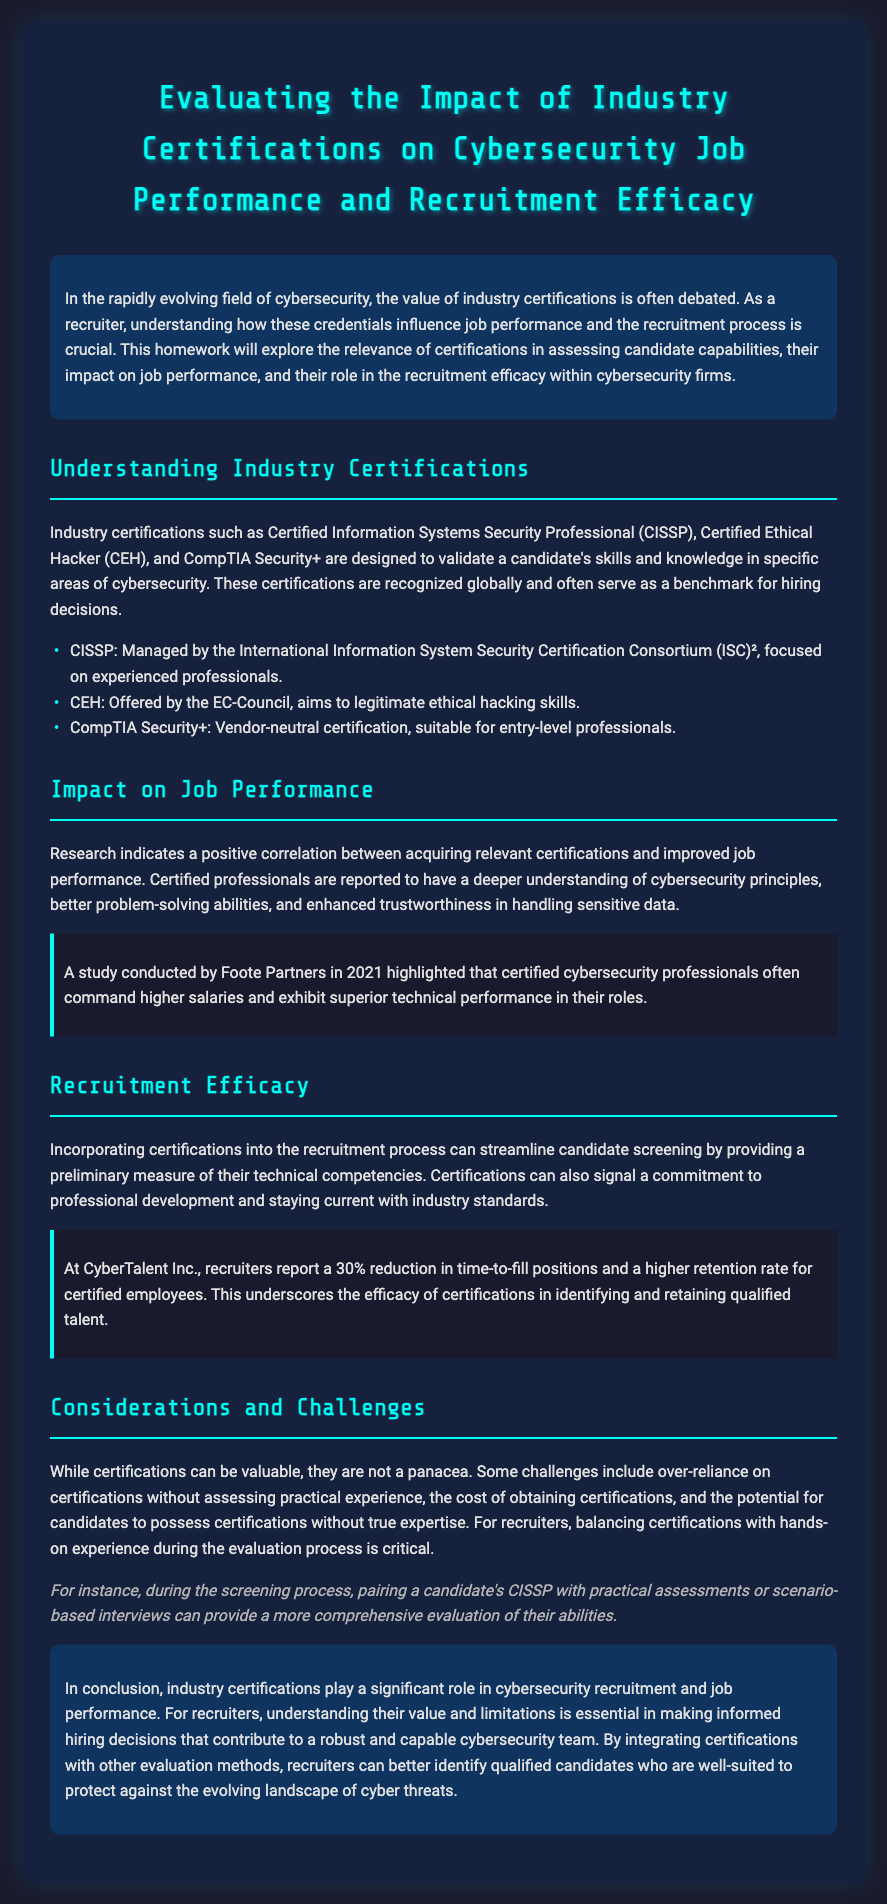What is the title of the homework? The title is presented prominently at the top of the document and is "Evaluating the Impact of Industry Certifications on Cybersecurity Job Performance and Recruitment Efficacy."
Answer: Evaluating the Impact of Industry Certifications on Cybersecurity Job Performance and Recruitment Efficacy Which organization manages the CISSP certification? The document specifies that the CISSP certification is managed by the International Information System Security Certification Consortium, also known as (ISC)².
Answer: (ISC)² What is the reported percentage reduction in time-to-fill positions at CyberTalent Inc.? The document mentions a "30% reduction in time-to-fill positions" at CyberTalent Inc. as a result of incorporating certifications into recruitment.
Answer: 30% What does the study by Foote Partners indicate about certified cybersecurity professionals? The study highlights certified cybersecurity professionals often command higher salaries and exhibit superior performance in their roles.
Answer: Superior performance What is one challenge mentioned about relying on certifications? One challenge is that over-reliance on certifications can occur without assessing practical experience.
Answer: Over-reliance on certifications Which certification is described as suitable for entry-level professionals? The document states that CompTIA Security+ is a vendor-neutral certification suitable for entry-level professionals.
Answer: CompTIA Security+ What is a critical evaluation method suggested for recruiters? The document suggests pairing a candidate's CISSP with practical assessments or scenario-based interviews for a comprehensive evaluation.
Answer: Practical assessments What is the focus of the CEH certification? The CEH certification aims to legitimate ethical hacking skills, as described in the document.
Answer: Ethical hacking skills 